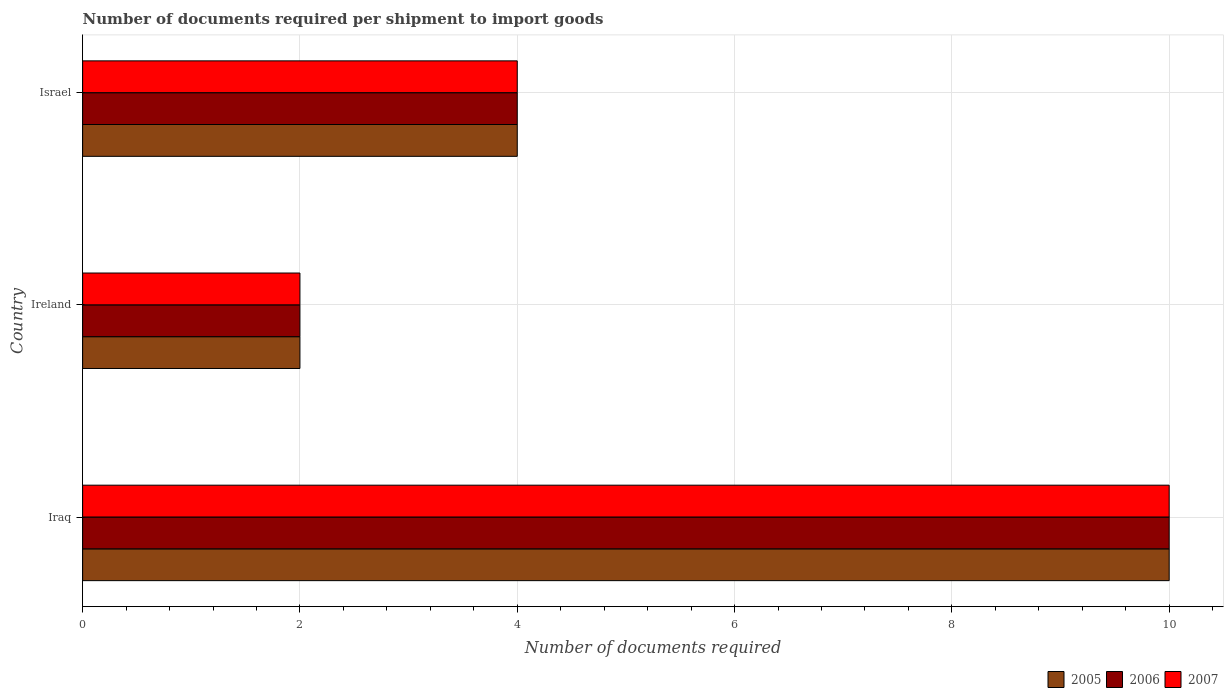How many different coloured bars are there?
Keep it short and to the point. 3. How many groups of bars are there?
Make the answer very short. 3. Are the number of bars per tick equal to the number of legend labels?
Make the answer very short. Yes. Are the number of bars on each tick of the Y-axis equal?
Your answer should be compact. Yes. How many bars are there on the 3rd tick from the top?
Offer a terse response. 3. What is the label of the 2nd group of bars from the top?
Offer a terse response. Ireland. What is the number of documents required per shipment to import goods in 2005 in Ireland?
Ensure brevity in your answer.  2. Across all countries, what is the maximum number of documents required per shipment to import goods in 2005?
Your response must be concise. 10. In which country was the number of documents required per shipment to import goods in 2006 maximum?
Provide a short and direct response. Iraq. In which country was the number of documents required per shipment to import goods in 2006 minimum?
Keep it short and to the point. Ireland. What is the total number of documents required per shipment to import goods in 2005 in the graph?
Provide a succinct answer. 16. What is the difference between the number of documents required per shipment to import goods in 2005 in Ireland and that in Israel?
Your answer should be very brief. -2. What is the difference between the number of documents required per shipment to import goods in 2005 in Israel and the number of documents required per shipment to import goods in 2007 in Ireland?
Give a very brief answer. 2. What is the average number of documents required per shipment to import goods in 2007 per country?
Provide a succinct answer. 5.33. What is the difference between the number of documents required per shipment to import goods in 2007 and number of documents required per shipment to import goods in 2005 in Iraq?
Offer a terse response. 0. What is the ratio of the number of documents required per shipment to import goods in 2005 in Iraq to that in Ireland?
Ensure brevity in your answer.  5. Is the number of documents required per shipment to import goods in 2005 in Iraq less than that in Ireland?
Your answer should be compact. No. Is the sum of the number of documents required per shipment to import goods in 2005 in Iraq and Israel greater than the maximum number of documents required per shipment to import goods in 2006 across all countries?
Offer a terse response. Yes. What does the 3rd bar from the bottom in Israel represents?
Your answer should be very brief. 2007. Is it the case that in every country, the sum of the number of documents required per shipment to import goods in 2006 and number of documents required per shipment to import goods in 2007 is greater than the number of documents required per shipment to import goods in 2005?
Provide a short and direct response. Yes. How many countries are there in the graph?
Keep it short and to the point. 3. Where does the legend appear in the graph?
Keep it short and to the point. Bottom right. How many legend labels are there?
Offer a very short reply. 3. How are the legend labels stacked?
Provide a short and direct response. Horizontal. What is the title of the graph?
Your answer should be compact. Number of documents required per shipment to import goods. Does "2005" appear as one of the legend labels in the graph?
Make the answer very short. Yes. What is the label or title of the X-axis?
Your answer should be very brief. Number of documents required. What is the Number of documents required in 2007 in Iraq?
Offer a terse response. 10. What is the Number of documents required of 2006 in Ireland?
Your answer should be compact. 2. What is the Number of documents required in 2007 in Ireland?
Offer a terse response. 2. What is the Number of documents required in 2005 in Israel?
Provide a short and direct response. 4. Across all countries, what is the minimum Number of documents required in 2005?
Ensure brevity in your answer.  2. Across all countries, what is the minimum Number of documents required of 2006?
Provide a succinct answer. 2. What is the difference between the Number of documents required in 2005 in Iraq and that in Ireland?
Keep it short and to the point. 8. What is the difference between the Number of documents required of 2006 in Iraq and that in Ireland?
Your answer should be very brief. 8. What is the difference between the Number of documents required in 2007 in Iraq and that in Ireland?
Your answer should be compact. 8. What is the difference between the Number of documents required of 2005 in Iraq and that in Israel?
Provide a short and direct response. 6. What is the difference between the Number of documents required of 2007 in Ireland and that in Israel?
Offer a terse response. -2. What is the difference between the Number of documents required of 2005 in Iraq and the Number of documents required of 2006 in Ireland?
Provide a short and direct response. 8. What is the difference between the Number of documents required of 2005 in Iraq and the Number of documents required of 2006 in Israel?
Your answer should be compact. 6. What is the difference between the Number of documents required of 2005 in Iraq and the Number of documents required of 2007 in Israel?
Ensure brevity in your answer.  6. What is the average Number of documents required in 2005 per country?
Offer a terse response. 5.33. What is the average Number of documents required in 2006 per country?
Offer a very short reply. 5.33. What is the average Number of documents required of 2007 per country?
Give a very brief answer. 5.33. What is the difference between the Number of documents required in 2006 and Number of documents required in 2007 in Iraq?
Your answer should be compact. 0. What is the difference between the Number of documents required of 2006 and Number of documents required of 2007 in Ireland?
Keep it short and to the point. 0. What is the difference between the Number of documents required in 2005 and Number of documents required in 2006 in Israel?
Make the answer very short. 0. What is the ratio of the Number of documents required in 2005 in Iraq to that in Ireland?
Your answer should be very brief. 5. What is the ratio of the Number of documents required in 2007 in Iraq to that in Ireland?
Offer a terse response. 5. What is the ratio of the Number of documents required in 2005 in Iraq to that in Israel?
Keep it short and to the point. 2.5. What is the ratio of the Number of documents required of 2007 in Iraq to that in Israel?
Make the answer very short. 2.5. What is the ratio of the Number of documents required of 2007 in Ireland to that in Israel?
Offer a very short reply. 0.5. What is the difference between the highest and the second highest Number of documents required of 2005?
Keep it short and to the point. 6. What is the difference between the highest and the second highest Number of documents required of 2007?
Your answer should be very brief. 6. What is the difference between the highest and the lowest Number of documents required in 2007?
Provide a succinct answer. 8. 